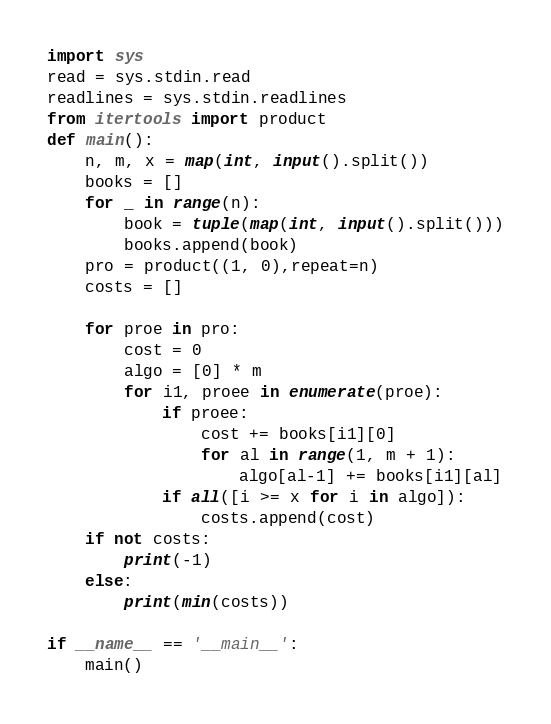<code> <loc_0><loc_0><loc_500><loc_500><_Python_>import sys
read = sys.stdin.read
readlines = sys.stdin.readlines
from itertools import product
def main():
    n, m, x = map(int, input().split())
    books = []
    for _ in range(n):
        book = tuple(map(int, input().split()))
        books.append(book)
    pro = product((1, 0),repeat=n)
    costs = []

    for proe in pro:
        cost = 0
        algo = [0] * m
        for i1, proee in enumerate(proe):
            if proee:
                cost += books[i1][0]
                for al in range(1, m + 1):
                    algo[al-1] += books[i1][al]
            if all([i >= x for i in algo]):
                costs.append(cost)
    if not costs:
        print(-1)
    else:
        print(min(costs))

if __name__ == '__main__':
    main()</code> 